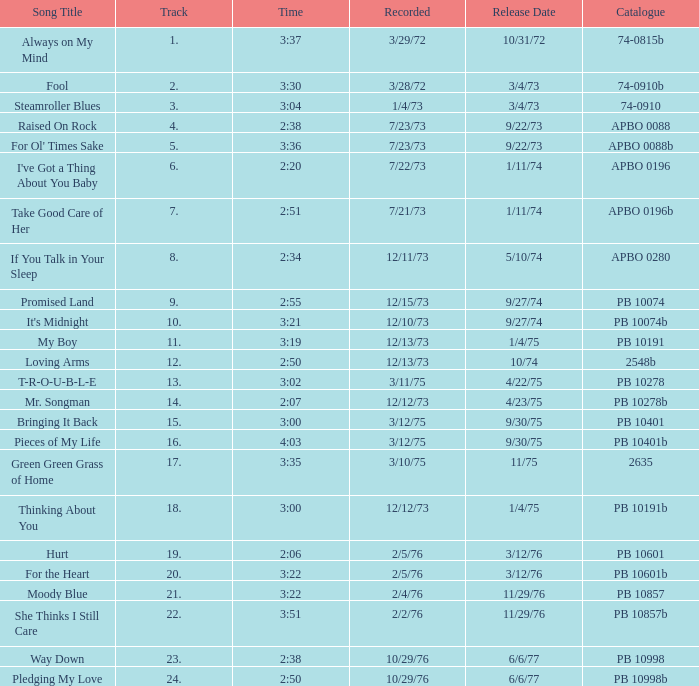Parse the table in full. {'header': ['Song Title', 'Track', 'Time', 'Recorded', 'Release Date', 'Catalogue'], 'rows': [['Always on My Mind', '1.', '3:37', '3/29/72', '10/31/72', '74-0815b'], ['Fool', '2.', '3:30', '3/28/72', '3/4/73', '74-0910b'], ['Steamroller Blues', '3.', '3:04', '1/4/73', '3/4/73', '74-0910'], ['Raised On Rock', '4.', '2:38', '7/23/73', '9/22/73', 'APBO 0088'], ["For Ol' Times Sake", '5.', '3:36', '7/23/73', '9/22/73', 'APBO 0088b'], ["I've Got a Thing About You Baby", '6.', '2:20', '7/22/73', '1/11/74', 'APBO 0196'], ['Take Good Care of Her', '7.', '2:51', '7/21/73', '1/11/74', 'APBO 0196b'], ['If You Talk in Your Sleep', '8.', '2:34', '12/11/73', '5/10/74', 'APBO 0280'], ['Promised Land', '9.', '2:55', '12/15/73', '9/27/74', 'PB 10074'], ["It's Midnight", '10.', '3:21', '12/10/73', '9/27/74', 'PB 10074b'], ['My Boy', '11.', '3:19', '12/13/73', '1/4/75', 'PB 10191'], ['Loving Arms', '12.', '2:50', '12/13/73', '10/74', '2548b'], ['T-R-O-U-B-L-E', '13.', '3:02', '3/11/75', '4/22/75', 'PB 10278'], ['Mr. Songman', '14.', '2:07', '12/12/73', '4/23/75', 'PB 10278b'], ['Bringing It Back', '15.', '3:00', '3/12/75', '9/30/75', 'PB 10401'], ['Pieces of My Life', '16.', '4:03', '3/12/75', '9/30/75', 'PB 10401b'], ['Green Green Grass of Home', '17.', '3:35', '3/10/75', '11/75', '2635'], ['Thinking About You', '18.', '3:00', '12/12/73', '1/4/75', 'PB 10191b'], ['Hurt', '19.', '2:06', '2/5/76', '3/12/76', 'PB 10601'], ['For the Heart', '20.', '3:22', '2/5/76', '3/12/76', 'PB 10601b'], ['Moody Blue', '21.', '3:22', '2/4/76', '11/29/76', 'PB 10857'], ['She Thinks I Still Care', '22.', '3:51', '2/2/76', '11/29/76', 'PB 10857b'], ['Way Down', '23.', '2:38', '10/29/76', '6/6/77', 'PB 10998'], ['Pledging My Love', '24.', '2:50', '10/29/76', '6/6/77', 'PB 10998b']]} Tell me the release date record on 10/29/76 and a time on 2:50 6/6/77. 